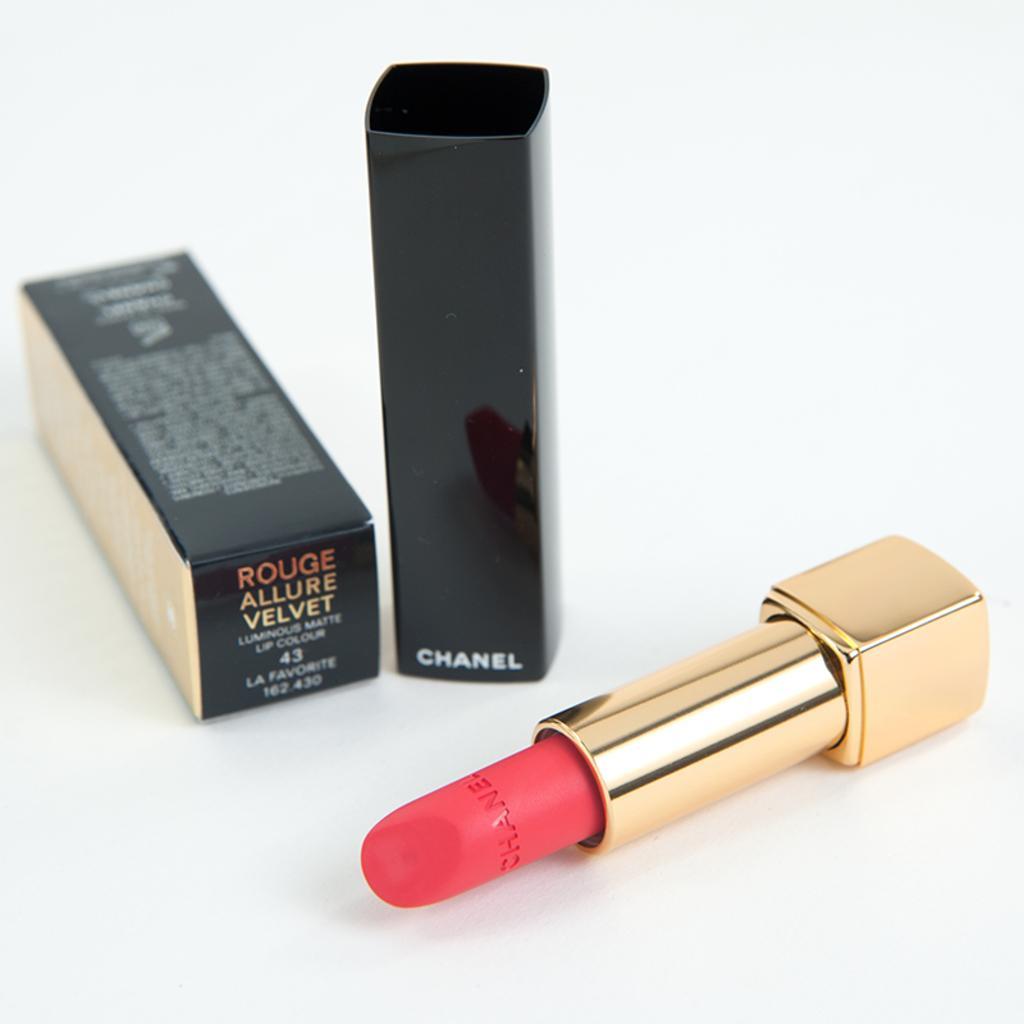Describe this image in one or two sentences. In this image we can see lipstick and carton placed on the table. 